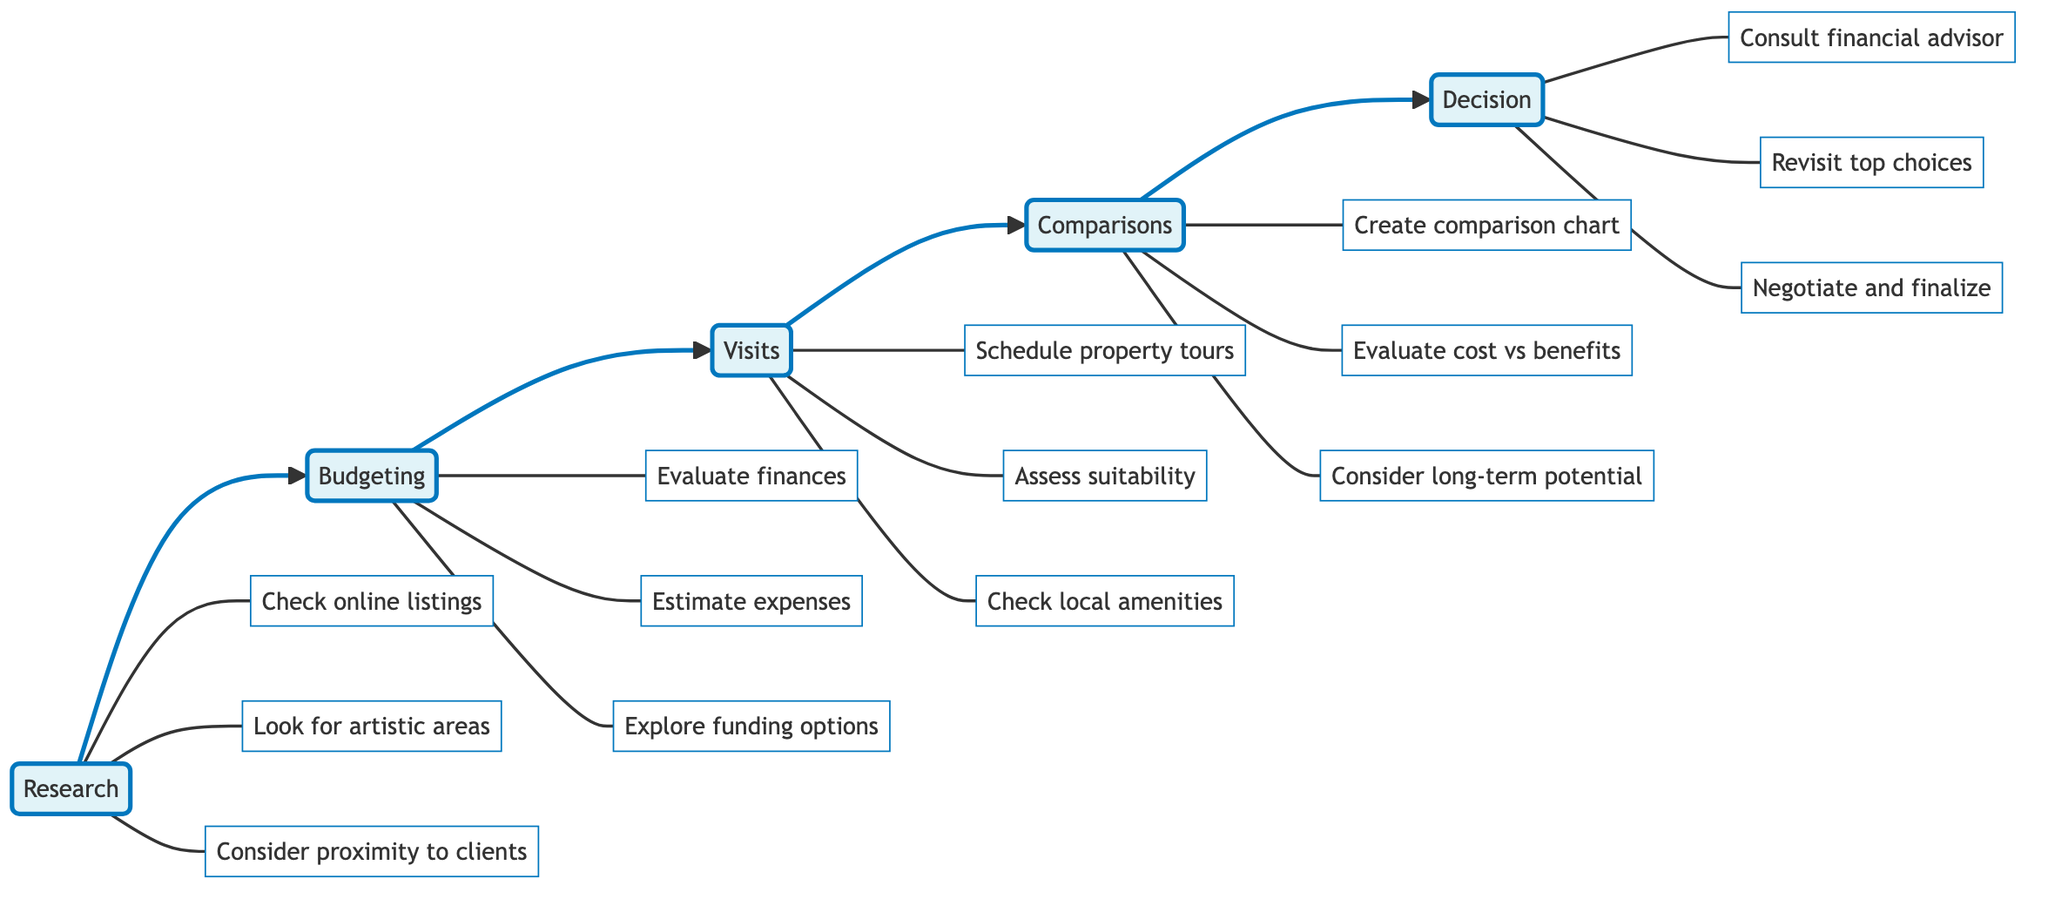What is the first step in the flowchart? The first step in the flowchart is labeled "Research," which is depicted as the initial node indicating where the process begins.
Answer: Research How many substeps are listed under Budgeting? There are three substeps listed under Budgeting, which include evaluating finances, estimating expenses, and exploring funding options.
Answer: 3 What does the "Visits" step involve? The "Visits" step involves touring shortlisted properties and assessing the physical attributes and suitability of these locations.
Answer: Tour shortlisted properties Which step comes after Research? The step that comes after Research is Budgeting, indicating that after identifying potential locations, one should determine financial limits.
Answer: Budgeting What is the last action in the Decision step? The last action in the Decision step is to negotiate terms and finalize the purchase or lease of the studio space.
Answer: Negotiate and finalize What are the main actions in the Comparisons step? The main actions in the Comparisons step include creating a comparison chart, evaluating cost versus benefits, and considering long-term potential.
Answer: Create a comparison chart, evaluate cost versus benefits, consider long-term potential Which node has the most substeps? The "Research" node has the most substeps with three different actions specified under it, indicating a thorough exploration phase.
Answer: Research Which step connects directly to Visits? The step that connects directly to Visits is Budgeting, indicating that after determining financial limits, touring properties is the next action.
Answer: Budgeting How many total steps are displayed in the flowchart? There are a total of five main steps displayed in the flowchart, detailing the entire process of determining the best studio location.
Answer: 5 